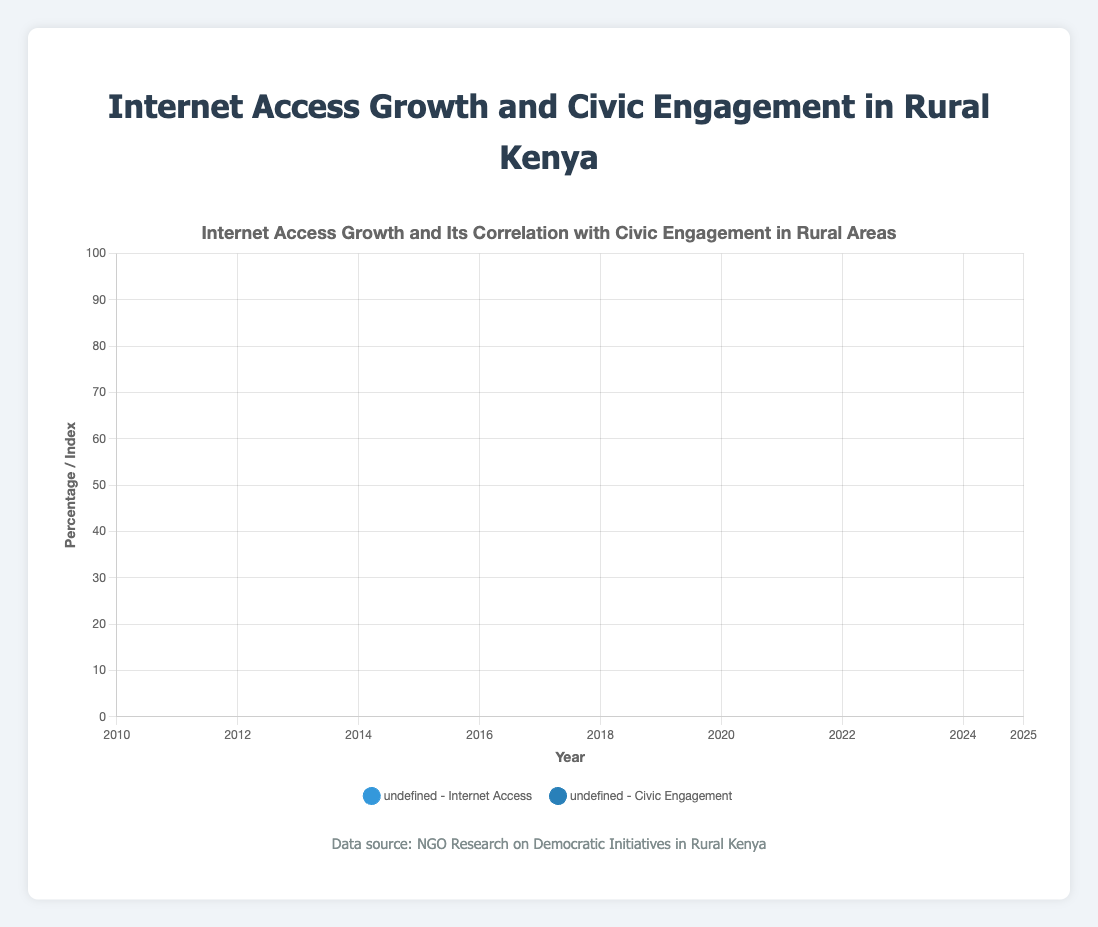What's the rate of increase in Internet Access Percentage in Nairobi from 2010 to 2025? To find the rate of increase, subtract the Internet Access Percentage in 2010 from that in 2025, then divide by the number of years between them. (79.3 - 15.2) / (2025 - 2010) = 64.1 / 15 ≈ 4.27% per year
Answer: 4.27% Which region had the highest Civic Engagement Index in 2025? Compare the Civic Engagement Indexes for Nairobi, Kericho, and Eldoret in 2025. Nairobi: 75.8, Kericho: 69.2, Eldoret: 72.1. The highest value is in Nairobi.
Answer: Nairobi How does the Internet Access Percentage in Kericho in 2020 compare to that in 2025? The Internet Access Percentage in Kericho in 2020 is 48.0 and in 2025 is 61.7. Thus, 61.7 is greater than 48.0.
Answer: It increased Which region shows the most significant change in Civic Engagement Index between 2010 and 2025? Calculate the change in Civic Engagement Index for each region: Nairobi: 75.8 - 27.4 = 48.4, Kericho: 69.2 - 20.1 = 49.1, Eldoret: 72.1 - 22.5 = 49.6. Eldoret shows the most significant change.
Answer: Eldoret What is the average Civic Engagement Index in 2015 across all regions? Sum the Civic Engagement Indexes for Nairobi, Kericho, and Eldoret in 2015, then divide by the number of regions. (45.2 + 32.8 + 33.4) / 3 ≈ 37.13
Answer: 37.13 Compare the trends in Internet Access Growth between Nairobi and Eldoret from 2010 to 2025. Both regions show an increasing trend in Internet Access Percentage. Nairobi: 15.2 to 79.3, Eldoret: 10.9 to 68.8. Nairobi has a steeper increase compared to Eldoret.
Answer: Nairobi has a steeper increase What year did Eldoret surpass 50% Internet Access? From the figure, Eldoret has above 50% Internet Access in 2020 and 2025. The first year it surpasses 50% is 2020.
Answer: 2020 What can be inferred about the correlation between Internet Access and Civic Engagement in these regions? Observing the trends, regions with higher Internet Access Percentages also show higher Civic Engagement Indexes. There seems to be a positive correlation between the two variables.
Answer: Positive correlation By how much did Kericho's Civic Engagement Index change from 2010 to 2020? Calculate the difference in Civic Engagement Index for Kericho between 2010 and 2020: 57.9 - 20.1 = 37.8
Answer: 37.8 What visual trend can you observe about Civic Engagement in Nairobi over the given years? The Civic Engagement Index in Nairobi steadily increases from 27.4 in 2010 to 75.8 in 2025, following an upward trend.
Answer: Upward trend 